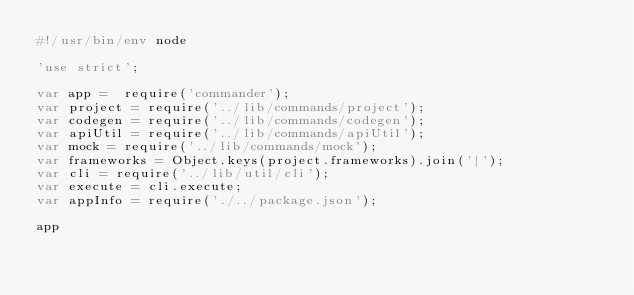<code> <loc_0><loc_0><loc_500><loc_500><_JavaScript_>#!/usr/bin/env node

'use strict';

var app =  require('commander');
var project = require('../lib/commands/project');
var codegen = require('../lib/commands/codegen');
var apiUtil = require('../lib/commands/apiUtil');
var mock = require('../lib/commands/mock');
var frameworks = Object.keys(project.frameworks).join('|');
var cli = require('../lib/util/cli');
var execute = cli.execute;
var appInfo = require('./../package.json');

app</code> 